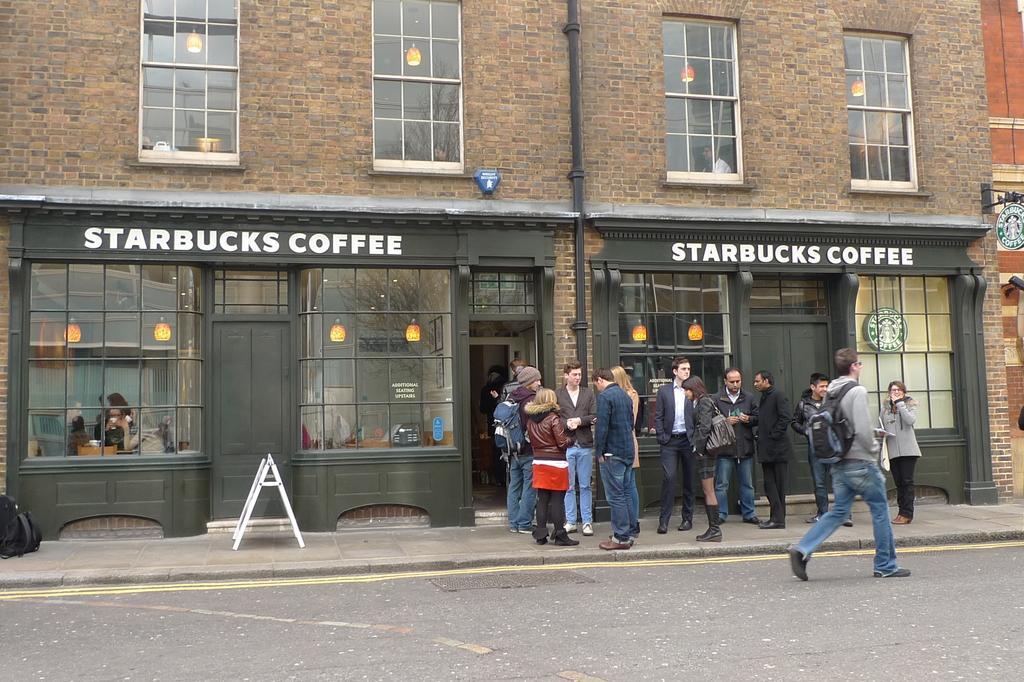Could you give a brief overview of what you see in this image? In this image we can see persons on the road. In addition to this we can see electric lights, building, windows, pipeline and a caution board. 